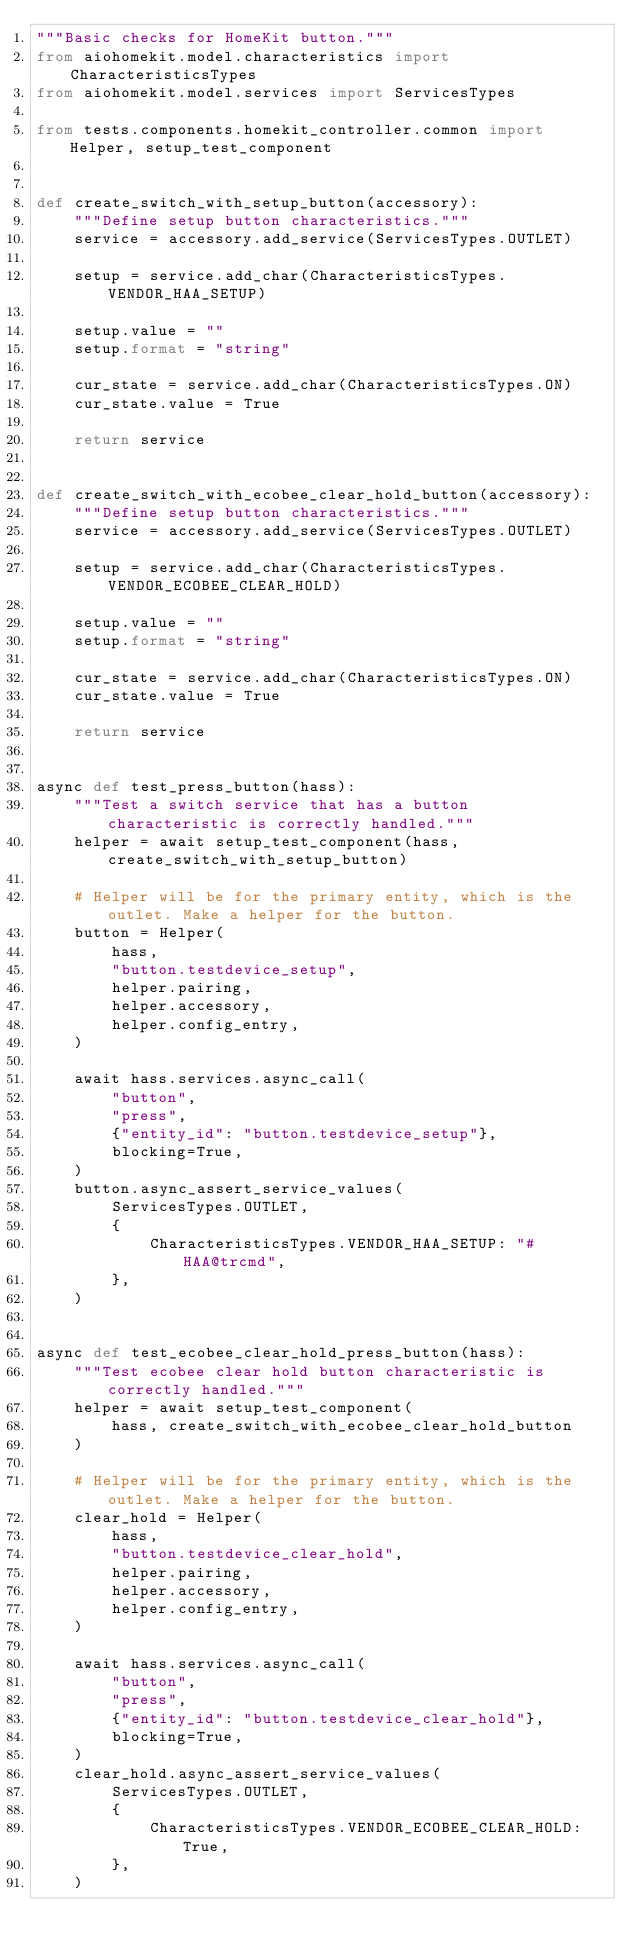Convert code to text. <code><loc_0><loc_0><loc_500><loc_500><_Python_>"""Basic checks for HomeKit button."""
from aiohomekit.model.characteristics import CharacteristicsTypes
from aiohomekit.model.services import ServicesTypes

from tests.components.homekit_controller.common import Helper, setup_test_component


def create_switch_with_setup_button(accessory):
    """Define setup button characteristics."""
    service = accessory.add_service(ServicesTypes.OUTLET)

    setup = service.add_char(CharacteristicsTypes.VENDOR_HAA_SETUP)

    setup.value = ""
    setup.format = "string"

    cur_state = service.add_char(CharacteristicsTypes.ON)
    cur_state.value = True

    return service


def create_switch_with_ecobee_clear_hold_button(accessory):
    """Define setup button characteristics."""
    service = accessory.add_service(ServicesTypes.OUTLET)

    setup = service.add_char(CharacteristicsTypes.VENDOR_ECOBEE_CLEAR_HOLD)

    setup.value = ""
    setup.format = "string"

    cur_state = service.add_char(CharacteristicsTypes.ON)
    cur_state.value = True

    return service


async def test_press_button(hass):
    """Test a switch service that has a button characteristic is correctly handled."""
    helper = await setup_test_component(hass, create_switch_with_setup_button)

    # Helper will be for the primary entity, which is the outlet. Make a helper for the button.
    button = Helper(
        hass,
        "button.testdevice_setup",
        helper.pairing,
        helper.accessory,
        helper.config_entry,
    )

    await hass.services.async_call(
        "button",
        "press",
        {"entity_id": "button.testdevice_setup"},
        blocking=True,
    )
    button.async_assert_service_values(
        ServicesTypes.OUTLET,
        {
            CharacteristicsTypes.VENDOR_HAA_SETUP: "#HAA@trcmd",
        },
    )


async def test_ecobee_clear_hold_press_button(hass):
    """Test ecobee clear hold button characteristic is correctly handled."""
    helper = await setup_test_component(
        hass, create_switch_with_ecobee_clear_hold_button
    )

    # Helper will be for the primary entity, which is the outlet. Make a helper for the button.
    clear_hold = Helper(
        hass,
        "button.testdevice_clear_hold",
        helper.pairing,
        helper.accessory,
        helper.config_entry,
    )

    await hass.services.async_call(
        "button",
        "press",
        {"entity_id": "button.testdevice_clear_hold"},
        blocking=True,
    )
    clear_hold.async_assert_service_values(
        ServicesTypes.OUTLET,
        {
            CharacteristicsTypes.VENDOR_ECOBEE_CLEAR_HOLD: True,
        },
    )
</code> 